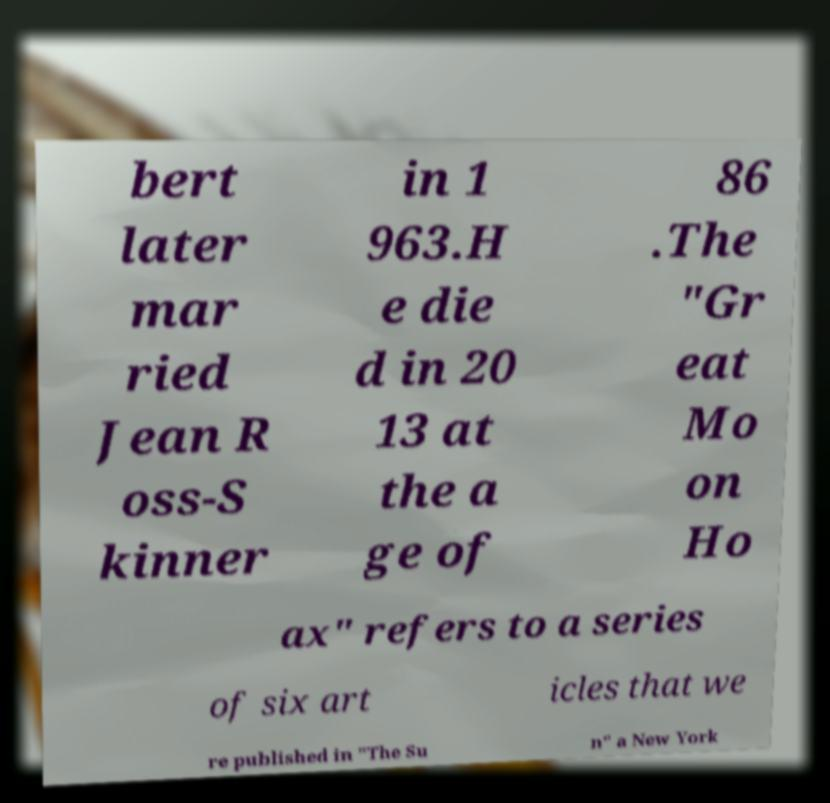There's text embedded in this image that I need extracted. Can you transcribe it verbatim? bert later mar ried Jean R oss-S kinner in 1 963.H e die d in 20 13 at the a ge of 86 .The "Gr eat Mo on Ho ax" refers to a series of six art icles that we re published in "The Su n" a New York 